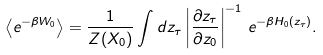Convert formula to latex. <formula><loc_0><loc_0><loc_500><loc_500>\left \langle e ^ { - \beta W _ { 0 } } \right \rangle = \frac { 1 } { Z ( X _ { 0 } ) } \int d z _ { \tau } \left | \frac { \partial z _ { \tau } } { \partial z _ { 0 } } \right | ^ { - 1 } \, e ^ { - \beta H _ { 0 } ( z _ { \tau } ) } .</formula> 